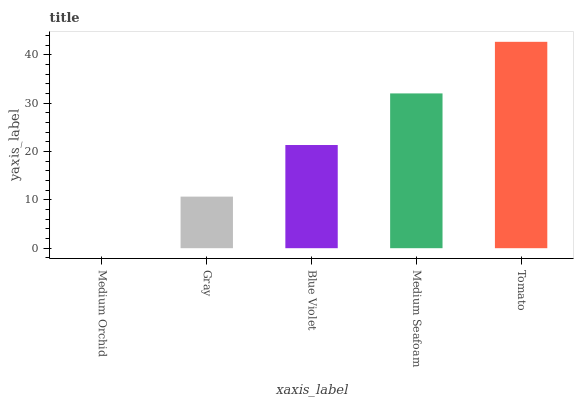Is Gray the minimum?
Answer yes or no. No. Is Gray the maximum?
Answer yes or no. No. Is Gray greater than Medium Orchid?
Answer yes or no. Yes. Is Medium Orchid less than Gray?
Answer yes or no. Yes. Is Medium Orchid greater than Gray?
Answer yes or no. No. Is Gray less than Medium Orchid?
Answer yes or no. No. Is Blue Violet the high median?
Answer yes or no. Yes. Is Blue Violet the low median?
Answer yes or no. Yes. Is Gray the high median?
Answer yes or no. No. Is Medium Seafoam the low median?
Answer yes or no. No. 